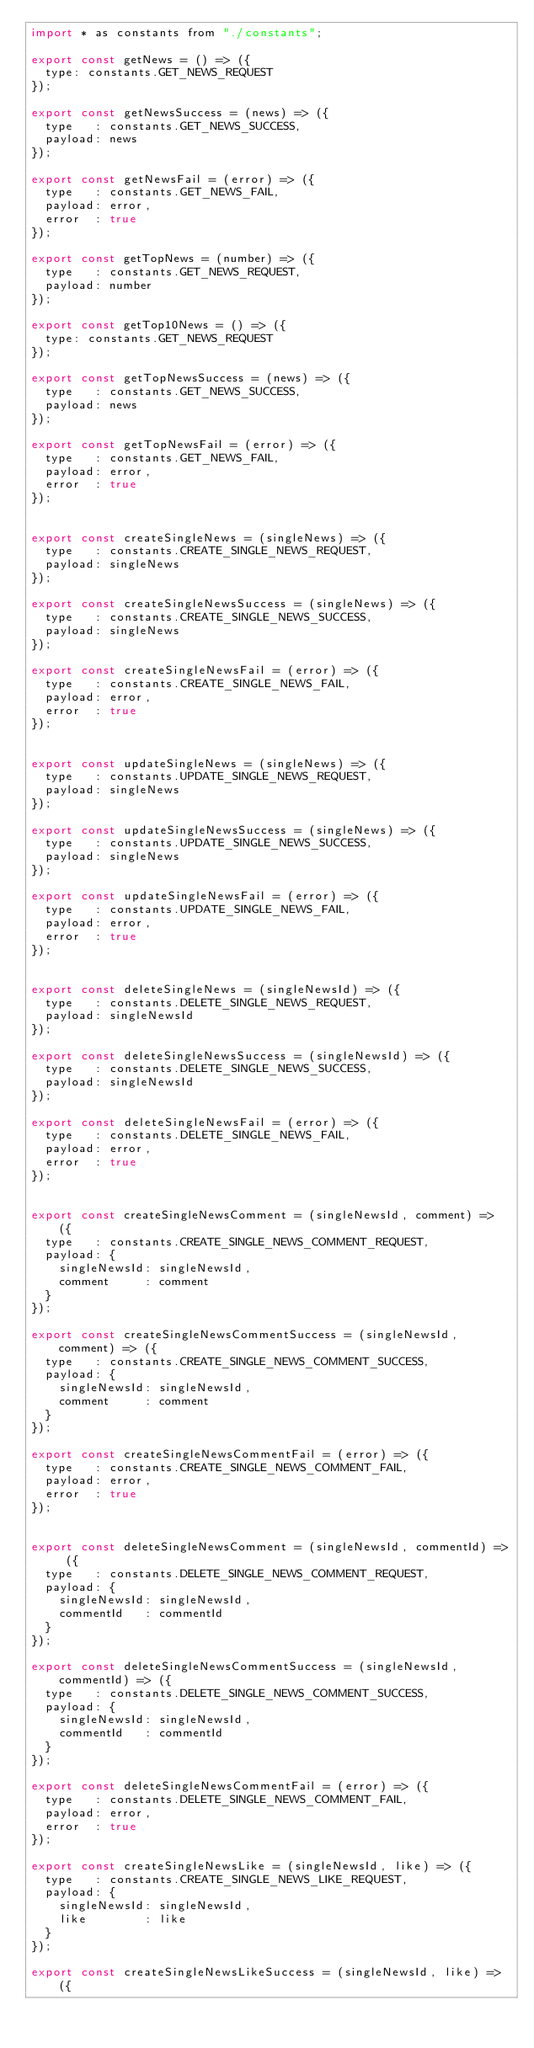<code> <loc_0><loc_0><loc_500><loc_500><_JavaScript_>import * as constants from "./constants";

export const getNews = () => ({
  type: constants.GET_NEWS_REQUEST
});

export const getNewsSuccess = (news) => ({
  type   : constants.GET_NEWS_SUCCESS,
  payload: news
});

export const getNewsFail = (error) => ({
  type   : constants.GET_NEWS_FAIL,
  payload: error,
  error  : true
});

export const getTopNews = (number) => ({
  type   : constants.GET_NEWS_REQUEST,
  payload: number
});

export const getTop10News = () => ({
  type: constants.GET_NEWS_REQUEST
});

export const getTopNewsSuccess = (news) => ({
  type   : constants.GET_NEWS_SUCCESS,
  payload: news
});

export const getTopNewsFail = (error) => ({
  type   : constants.GET_NEWS_FAIL,
  payload: error,
  error  : true
});


export const createSingleNews = (singleNews) => ({
  type   : constants.CREATE_SINGLE_NEWS_REQUEST,
  payload: singleNews
});

export const createSingleNewsSuccess = (singleNews) => ({
  type   : constants.CREATE_SINGLE_NEWS_SUCCESS,
  payload: singleNews
});

export const createSingleNewsFail = (error) => ({
  type   : constants.CREATE_SINGLE_NEWS_FAIL,
  payload: error,
  error  : true
});


export const updateSingleNews = (singleNews) => ({
  type   : constants.UPDATE_SINGLE_NEWS_REQUEST,
  payload: singleNews
});

export const updateSingleNewsSuccess = (singleNews) => ({
  type   : constants.UPDATE_SINGLE_NEWS_SUCCESS,
  payload: singleNews
});

export const updateSingleNewsFail = (error) => ({
  type   : constants.UPDATE_SINGLE_NEWS_FAIL,
  payload: error,
  error  : true
});


export const deleteSingleNews = (singleNewsId) => ({
  type   : constants.DELETE_SINGLE_NEWS_REQUEST,
  payload: singleNewsId
});

export const deleteSingleNewsSuccess = (singleNewsId) => ({
  type   : constants.DELETE_SINGLE_NEWS_SUCCESS,
  payload: singleNewsId
});

export const deleteSingleNewsFail = (error) => ({
  type   : constants.DELETE_SINGLE_NEWS_FAIL,
  payload: error,
  error  : true
});


export const createSingleNewsComment = (singleNewsId, comment) => ({
  type   : constants.CREATE_SINGLE_NEWS_COMMENT_REQUEST,
  payload: {
    singleNewsId: singleNewsId,
    comment     : comment
  }
});

export const createSingleNewsCommentSuccess = (singleNewsId, comment) => ({
  type   : constants.CREATE_SINGLE_NEWS_COMMENT_SUCCESS,
  payload: {
    singleNewsId: singleNewsId,
    comment     : comment
  }
});

export const createSingleNewsCommentFail = (error) => ({
  type   : constants.CREATE_SINGLE_NEWS_COMMENT_FAIL,
  payload: error,
  error  : true
});


export const deleteSingleNewsComment = (singleNewsId, commentId) => ({
  type   : constants.DELETE_SINGLE_NEWS_COMMENT_REQUEST,
  payload: {
    singleNewsId: singleNewsId,
    commentId   : commentId
  }
});

export const deleteSingleNewsCommentSuccess = (singleNewsId, commentId) => ({
  type   : constants.DELETE_SINGLE_NEWS_COMMENT_SUCCESS,
  payload: {
    singleNewsId: singleNewsId,
    commentId   : commentId
  }
});

export const deleteSingleNewsCommentFail = (error) => ({
  type   : constants.DELETE_SINGLE_NEWS_COMMENT_FAIL,
  payload: error,
  error  : true
});

export const createSingleNewsLike = (singleNewsId, like) => ({
  type   : constants.CREATE_SINGLE_NEWS_LIKE_REQUEST,
  payload: {
    singleNewsId: singleNewsId,
    like        : like
  }
});

export const createSingleNewsLikeSuccess = (singleNewsId, like) => ({</code> 